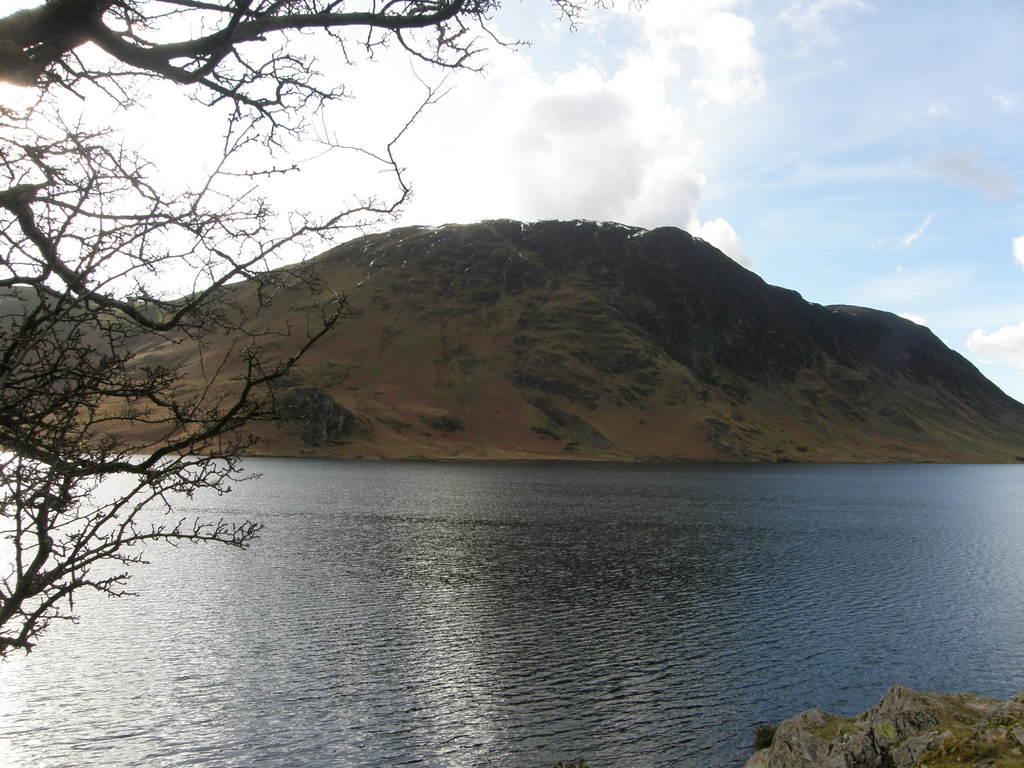Please provide a concise description of this image. In this image we can see trees, water and in the background of the image there are some mountains and there is cloudy sky. 